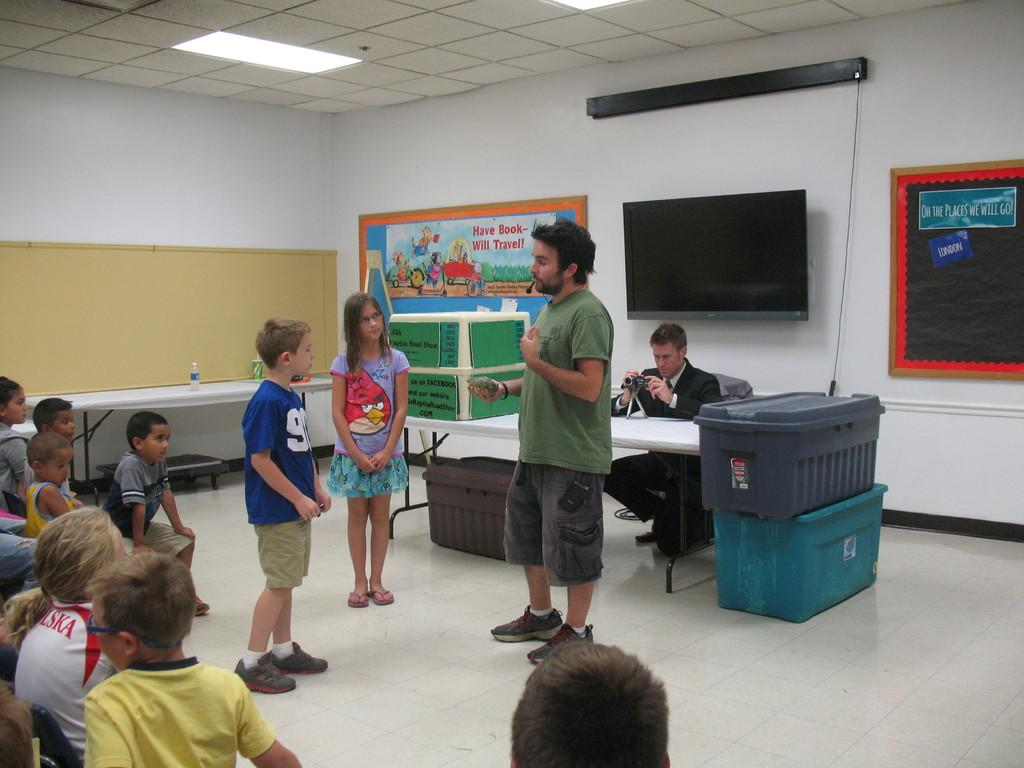How many people are in the image? There is a group of people in the image, but the exact number is not specified. What is the main object in the center of the image? There is a table in the image. What type of objects can be seen near the table? There are baskets in the image. What can be seen in the background of the image? There is a television, posters, and a roof. Who controls the scene in the image? There is no indication in the image that anyone is controlling the scene. What type of lumber is used to construct the roof in the image? There is no mention of lumber or the construction of the roof in the image. 